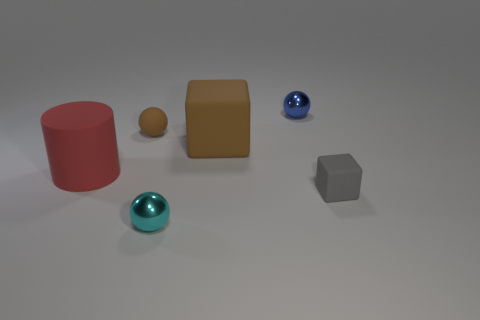Subtract all cyan balls. How many balls are left? 2 Subtract all small metallic spheres. How many spheres are left? 1 Subtract 2 balls. How many balls are left? 1 Subtract all cubes. How many objects are left? 4 Subtract all purple cylinders. How many gray cubes are left? 1 Add 2 cyan balls. How many objects exist? 8 Subtract all green spheres. Subtract all brown cylinders. How many spheres are left? 3 Subtract all blue shiny spheres. Subtract all brown shiny balls. How many objects are left? 5 Add 3 brown blocks. How many brown blocks are left? 4 Add 5 cyan rubber cylinders. How many cyan rubber cylinders exist? 5 